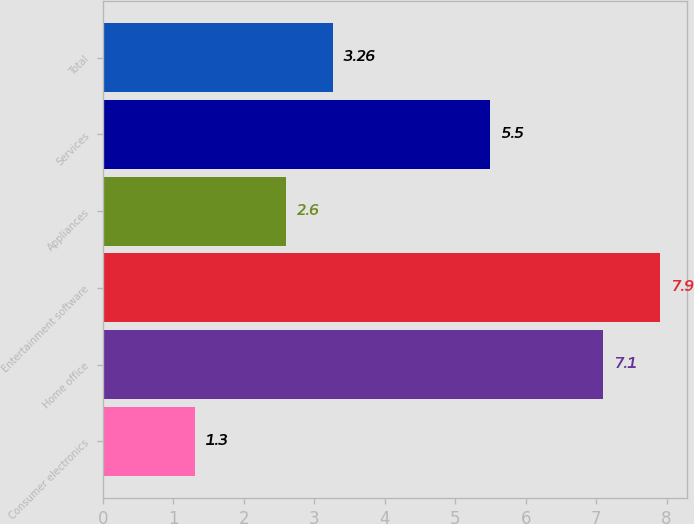Convert chart. <chart><loc_0><loc_0><loc_500><loc_500><bar_chart><fcel>Consumer electronics<fcel>Home office<fcel>Entertainment software<fcel>Appliances<fcel>Services<fcel>Total<nl><fcel>1.3<fcel>7.1<fcel>7.9<fcel>2.6<fcel>5.5<fcel>3.26<nl></chart> 